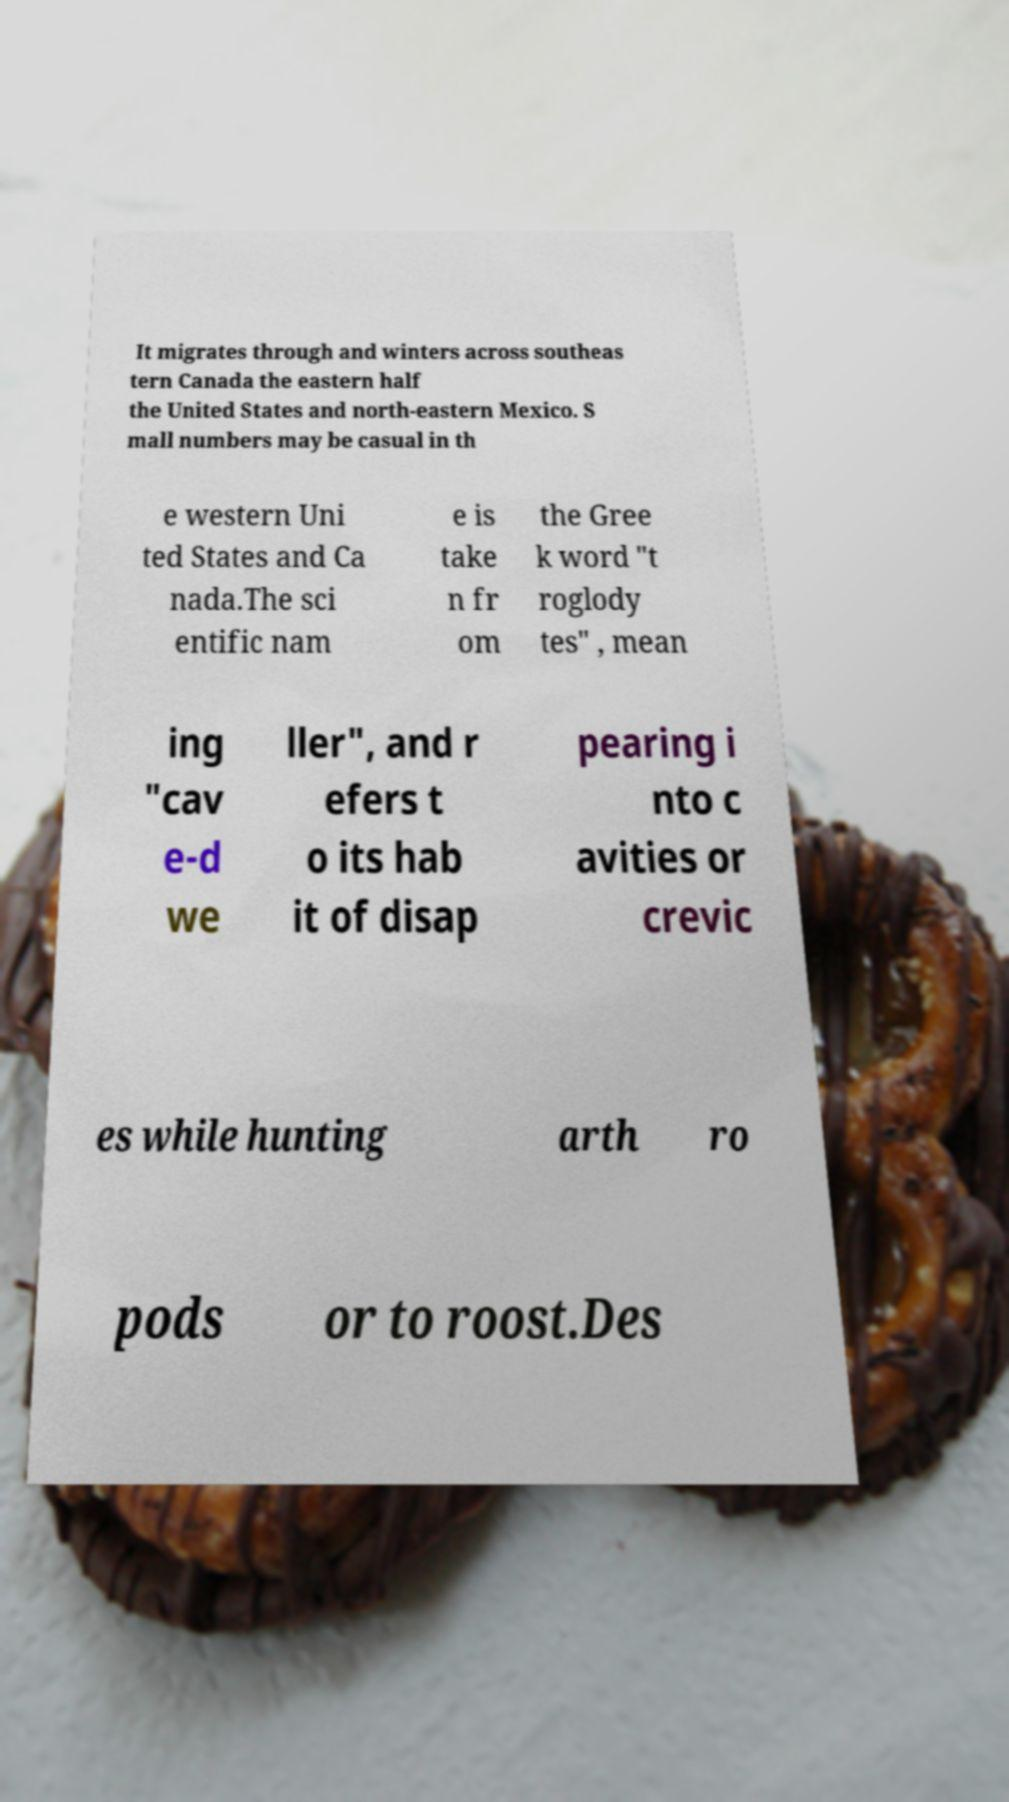Could you assist in decoding the text presented in this image and type it out clearly? It migrates through and winters across southeas tern Canada the eastern half the United States and north-eastern Mexico. S mall numbers may be casual in th e western Uni ted States and Ca nada.The sci entific nam e is take n fr om the Gree k word "t roglody tes" , mean ing "cav e-d we ller", and r efers t o its hab it of disap pearing i nto c avities or crevic es while hunting arth ro pods or to roost.Des 